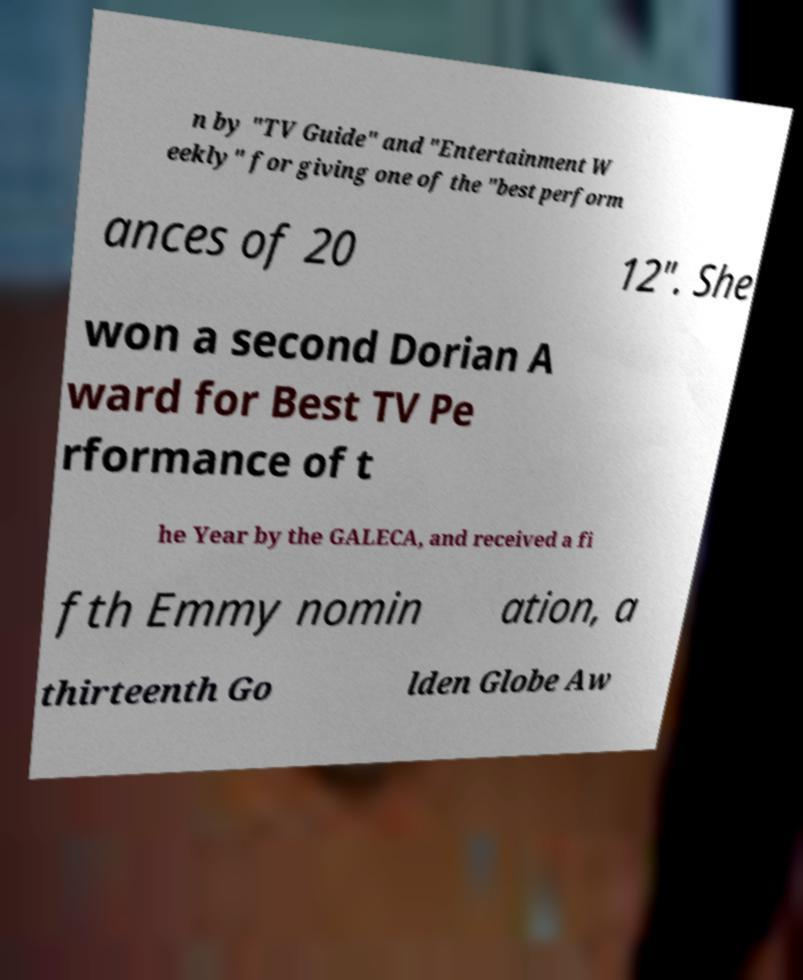Can you read and provide the text displayed in the image?This photo seems to have some interesting text. Can you extract and type it out for me? n by "TV Guide" and "Entertainment W eekly" for giving one of the "best perform ances of 20 12". She won a second Dorian A ward for Best TV Pe rformance of t he Year by the GALECA, and received a fi fth Emmy nomin ation, a thirteenth Go lden Globe Aw 